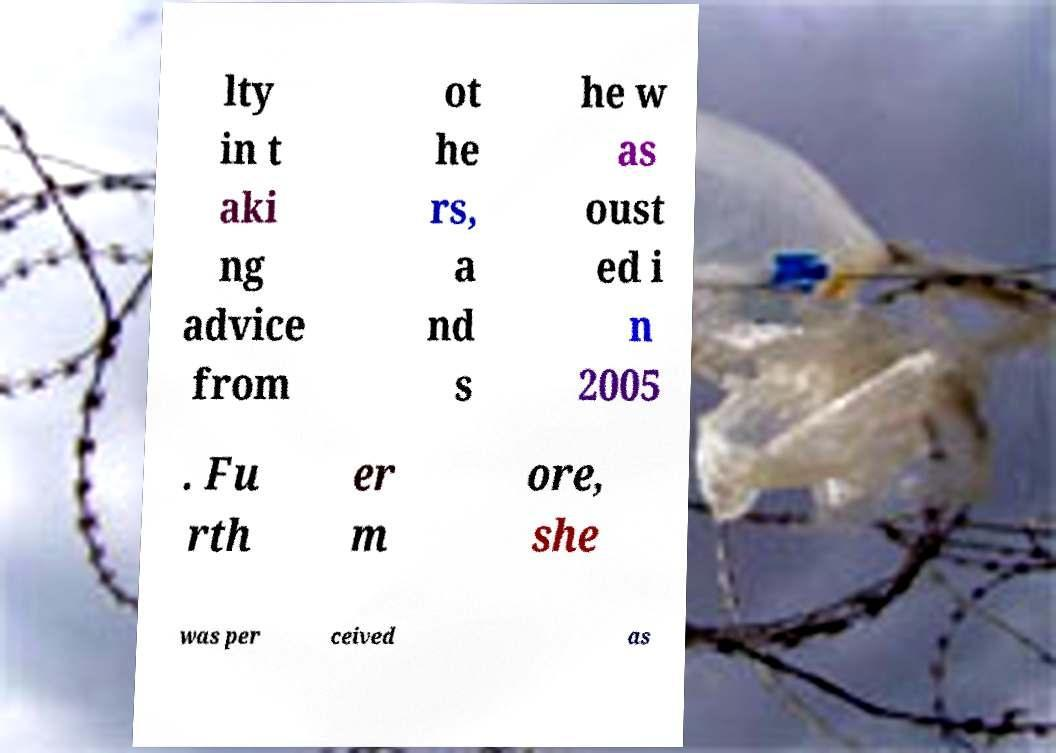For documentation purposes, I need the text within this image transcribed. Could you provide that? lty in t aki ng advice from ot he rs, a nd s he w as oust ed i n 2005 . Fu rth er m ore, she was per ceived as 